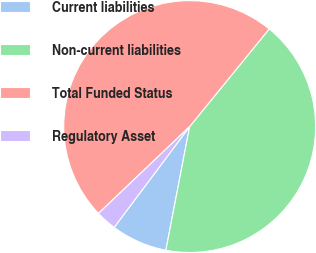<chart> <loc_0><loc_0><loc_500><loc_500><pie_chart><fcel>Current liabilities<fcel>Non-current liabilities<fcel>Total Funded Status<fcel>Regulatory Asset<nl><fcel>7.2%<fcel>42.15%<fcel>47.99%<fcel>2.66%<nl></chart> 